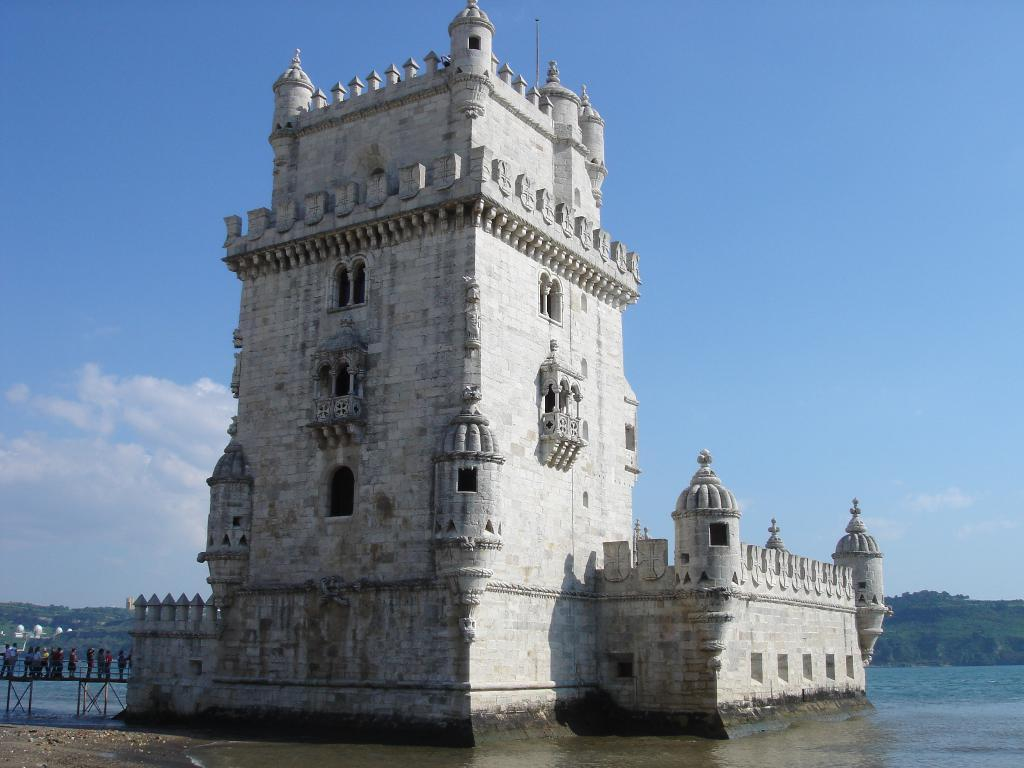What structure is the main subject of the image? There is a building in the image. Where are the people located in relation to the building? The people are standing on a bridge beside the building. What can be seen in the background of the image? There is water, mountains, and the sky visible in the background of the image. What is the condition of the sky in the image? Clouds are present in the sky. How many mice are crawling on the attention-grabbing hose in the image? There is no hose or mice present in the image. 